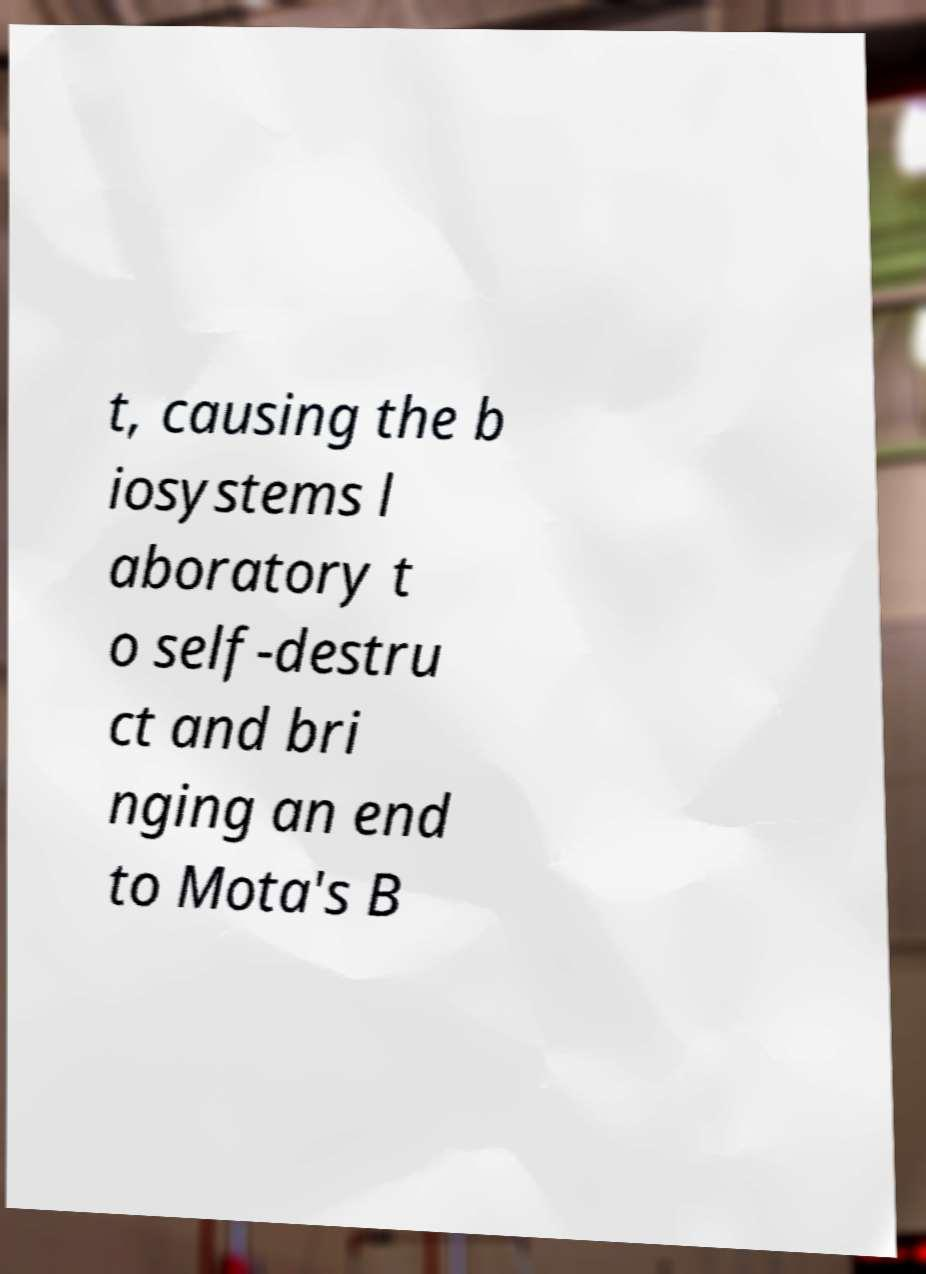Please identify and transcribe the text found in this image. t, causing the b iosystems l aboratory t o self-destru ct and bri nging an end to Mota's B 